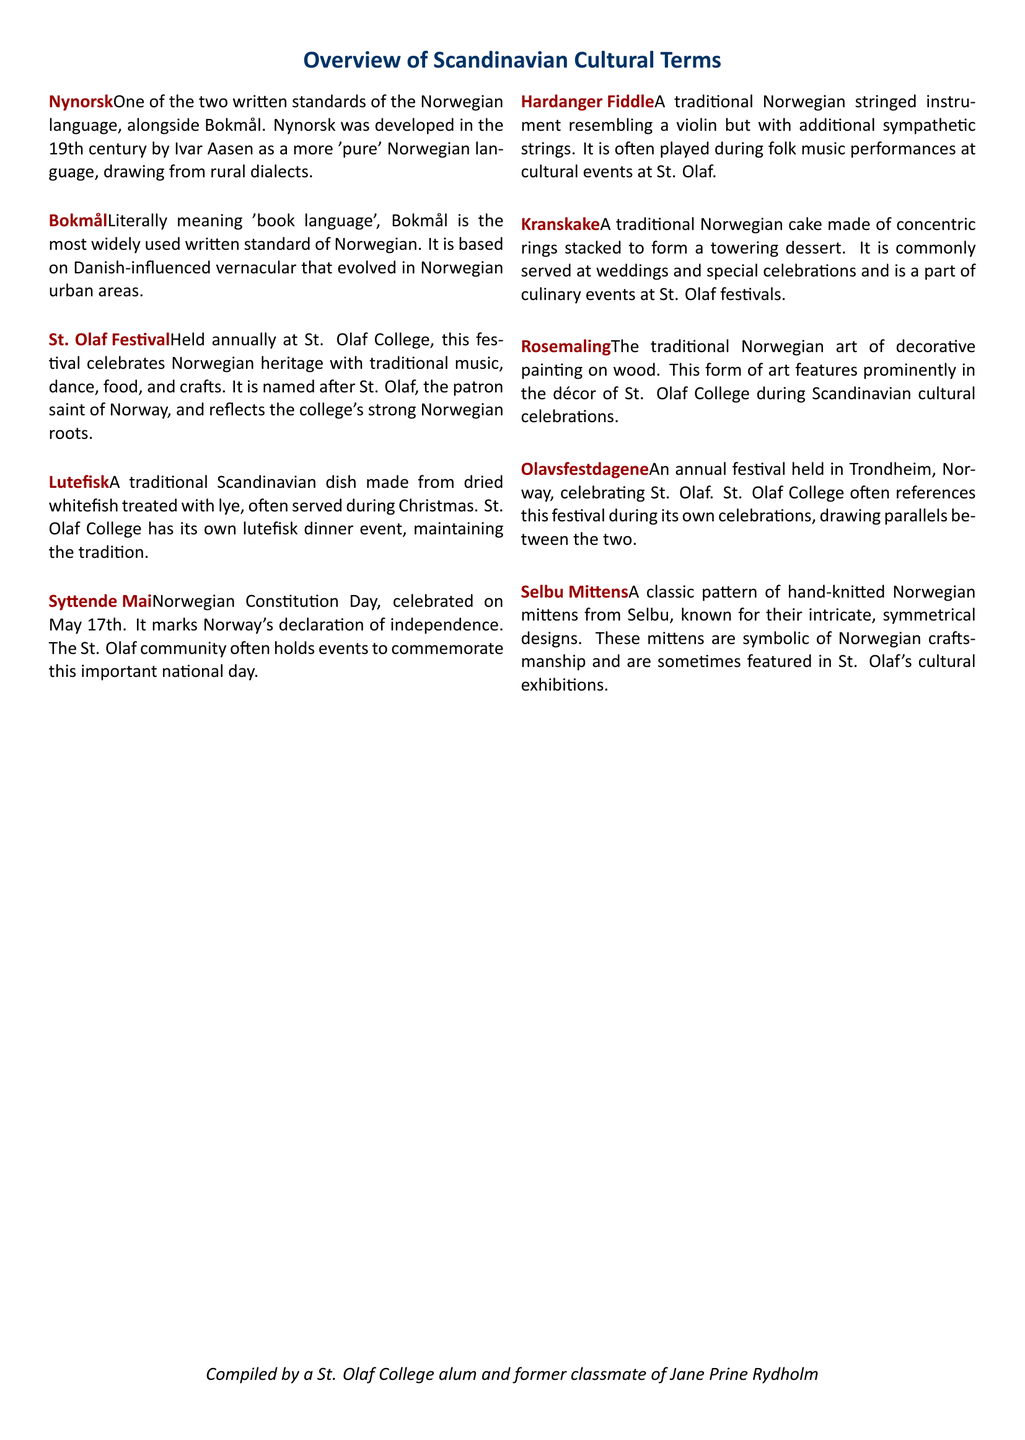What is Nynorsk? Nynorsk is defined as one of the two written standards of the Norwegian language, developed in the 19th century.
Answer: One of the two written standards of the Norwegian language What is the significance of Syttende Mai? Syttende Mai is celebrated on May 17th and marks Norway's declaration of independence.
Answer: Norwegian Constitution Day How is Lutefisk traditionally prepared? Lutefisk is made from dried whitefish treated with lye, often served during Christmas.
Answer: Dried whitefish treated with lye What traditional event is held annually at St. Olaf College? The St. Olaf Festival celebrates Norwegian heritage with music, dance, food, and crafts.
Answer: St. Olaf Festival Which traditional dish is commonly served at St. Olaf College events? Lutefisk is mentioned as a dish that is a part of events at St. Olaf College.
Answer: Lutefisk What instrument is associated with folk music performances at St. Olaf? The Hardanger Fiddle is a traditional stringed instrument played during cultural events at St. Olaf.
Answer: Hardanger Fiddle What is Kranskake commonly served at? Kranskake is a traditional cake served at weddings and special celebrations, featured at St. Olaf festivals.
Answer: Weddings and special celebrations What type of art is Rosemaling? Rosemaling is described as the traditional Norwegian art of decorative painting on wood.
Answer: Decorative painting on wood What festival is referenced by St. Olaf College that celebrates St. Olaf? Olavsfestdagene is an annual festival in Trondheim, Norway, celebrating St. Olaf.
Answer: Olavsfestdagene What are Selbu Mittens known for? Selbu Mittens are known for intricate, symmetrical designs and symbolize Norwegian craftsmanship.
Answer: Intricate, symmetrical designs 